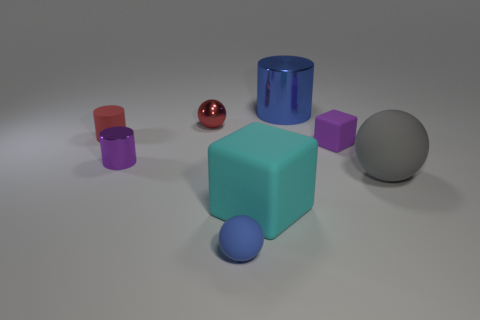Add 2 small blue metal cylinders. How many objects exist? 10 Subtract all cubes. How many objects are left? 6 Subtract all purple balls. Subtract all large blue things. How many objects are left? 7 Add 1 rubber spheres. How many rubber spheres are left? 3 Add 6 purple metal objects. How many purple metal objects exist? 7 Subtract 0 brown cubes. How many objects are left? 8 